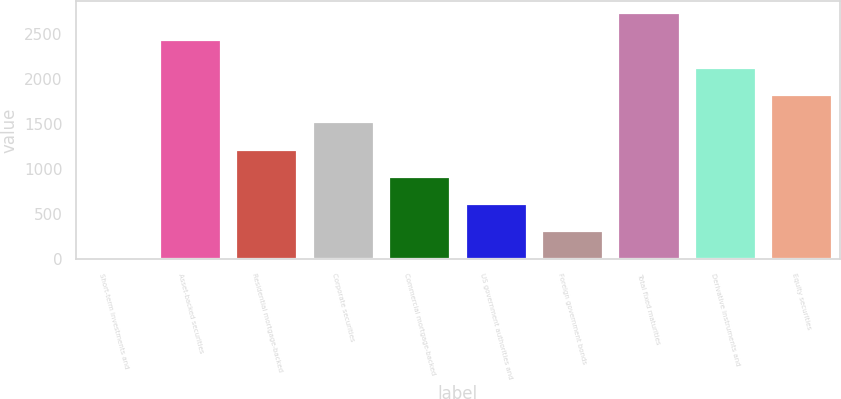Convert chart to OTSL. <chart><loc_0><loc_0><loc_500><loc_500><bar_chart><fcel>Short-term investments and<fcel>Asset-backed securities<fcel>Residential mortgage-backed<fcel>Corporate securities<fcel>Commercial mortgage-backed<fcel>US government authorities and<fcel>Foreign government bonds<fcel>Total fixed maturities<fcel>Derivative instruments and<fcel>Equity securities<nl><fcel>5<fcel>2427.4<fcel>1216.2<fcel>1519<fcel>913.4<fcel>610.6<fcel>307.8<fcel>2730.2<fcel>2124.6<fcel>1821.8<nl></chart> 